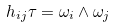<formula> <loc_0><loc_0><loc_500><loc_500>h _ { i j } \tau = \omega _ { i } \wedge \omega _ { j }</formula> 